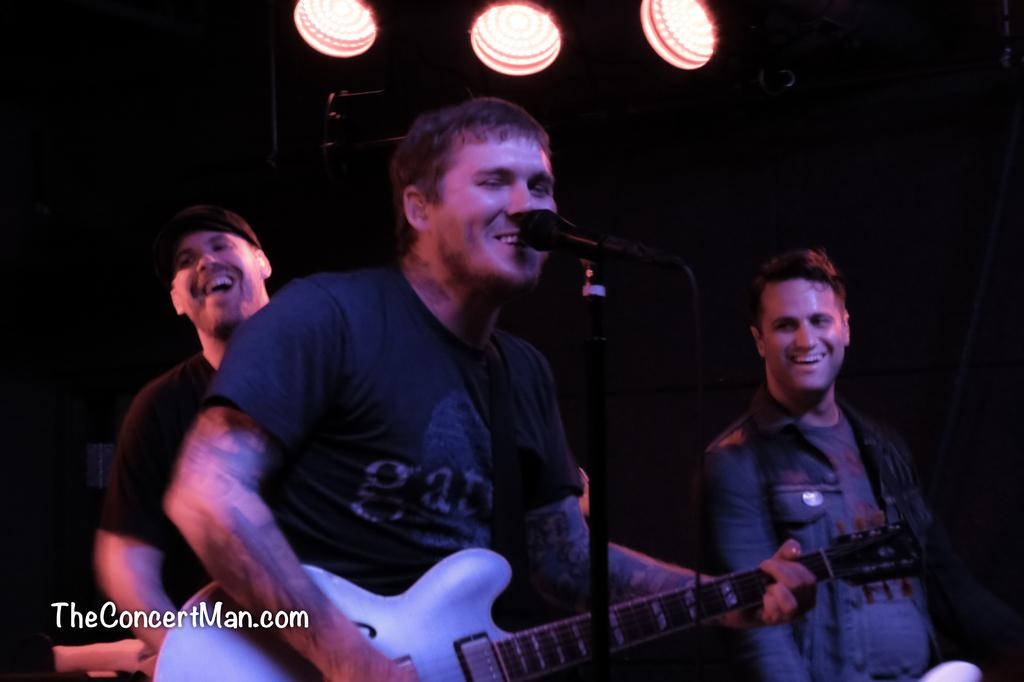What is the person in the image holding? The person is holding a guitar. What is in front of the person? There is a microphone in front of the person. Can you describe the background of the image? There are two other persons and lights visible in the background of the image. How far away is the room from the person in the image? The image does not provide information about the distance between the person and a room, as it only shows the person holding a guitar and standing in front of a microphone. 